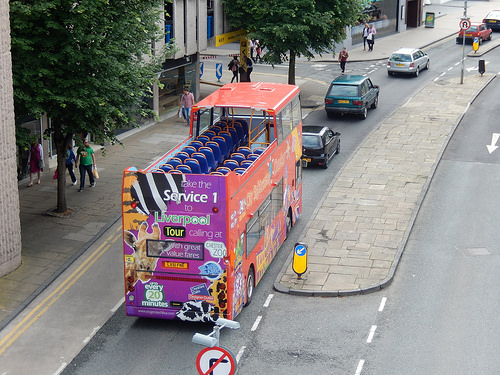<image>
Is the bus behind the car? Yes. From this viewpoint, the bus is positioned behind the car, with the car partially or fully occluding the bus. 